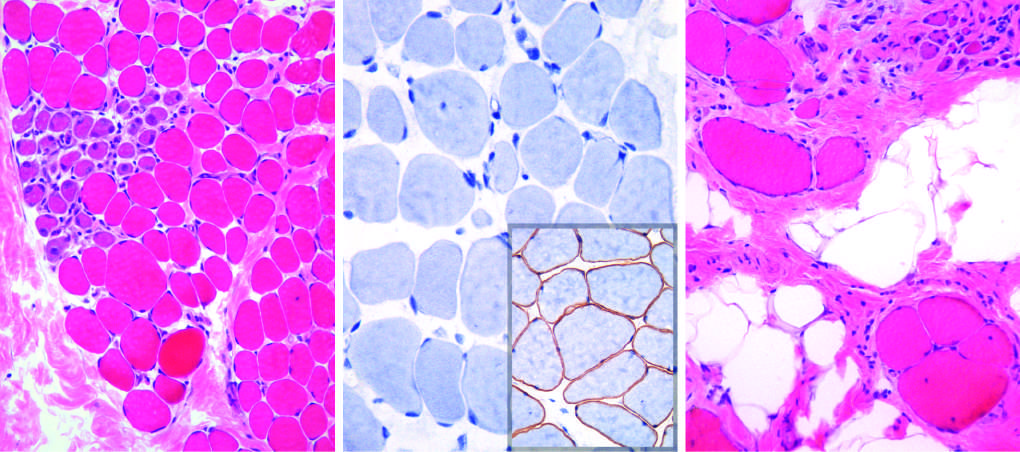s the extensive subcutaneous fibrosis a cluster of basophilic regenerating myofibers and slight endomysial fibrosis, seen as focal pink-staining connective tissue between myofibers?
Answer the question using a single word or phrase. No 